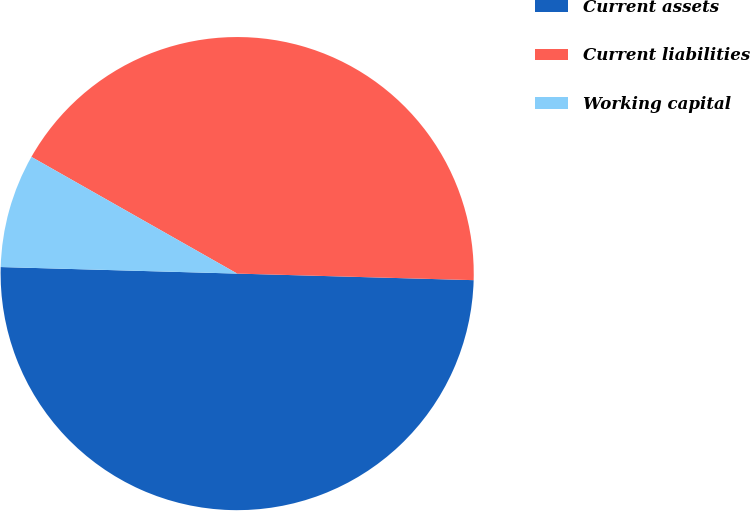Convert chart to OTSL. <chart><loc_0><loc_0><loc_500><loc_500><pie_chart><fcel>Current assets<fcel>Current liabilities<fcel>Working capital<nl><fcel>50.0%<fcel>42.23%<fcel>7.77%<nl></chart> 